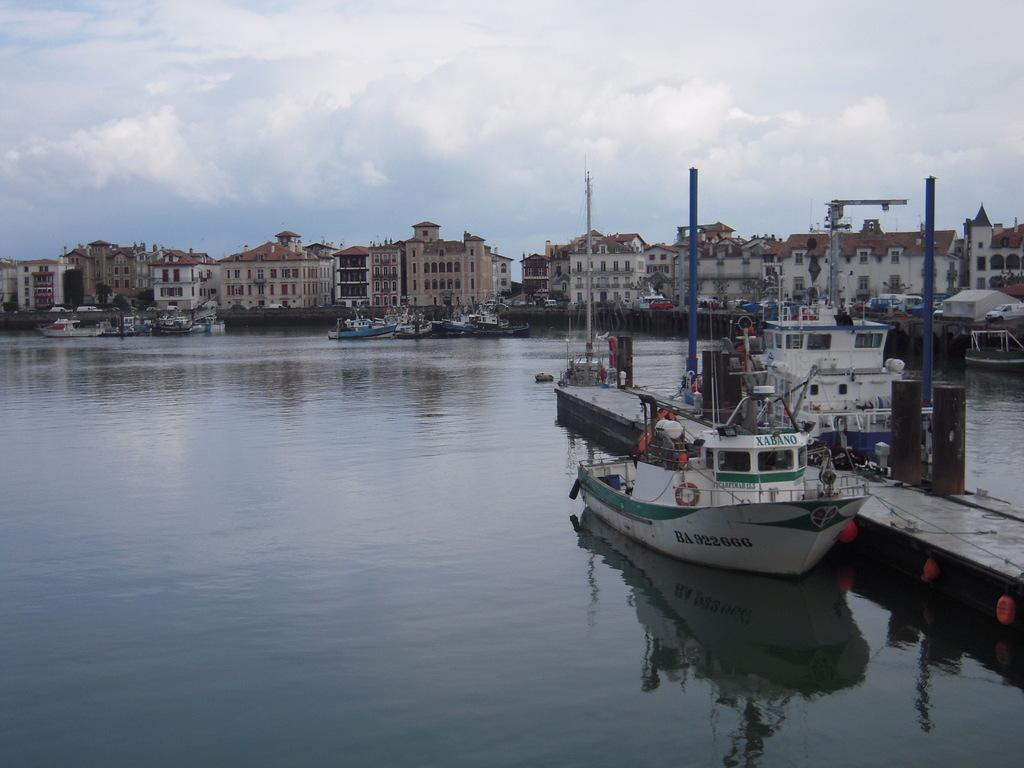<image>
Describe the image concisely. A boat is called Xabano and is sitting at the dock. 